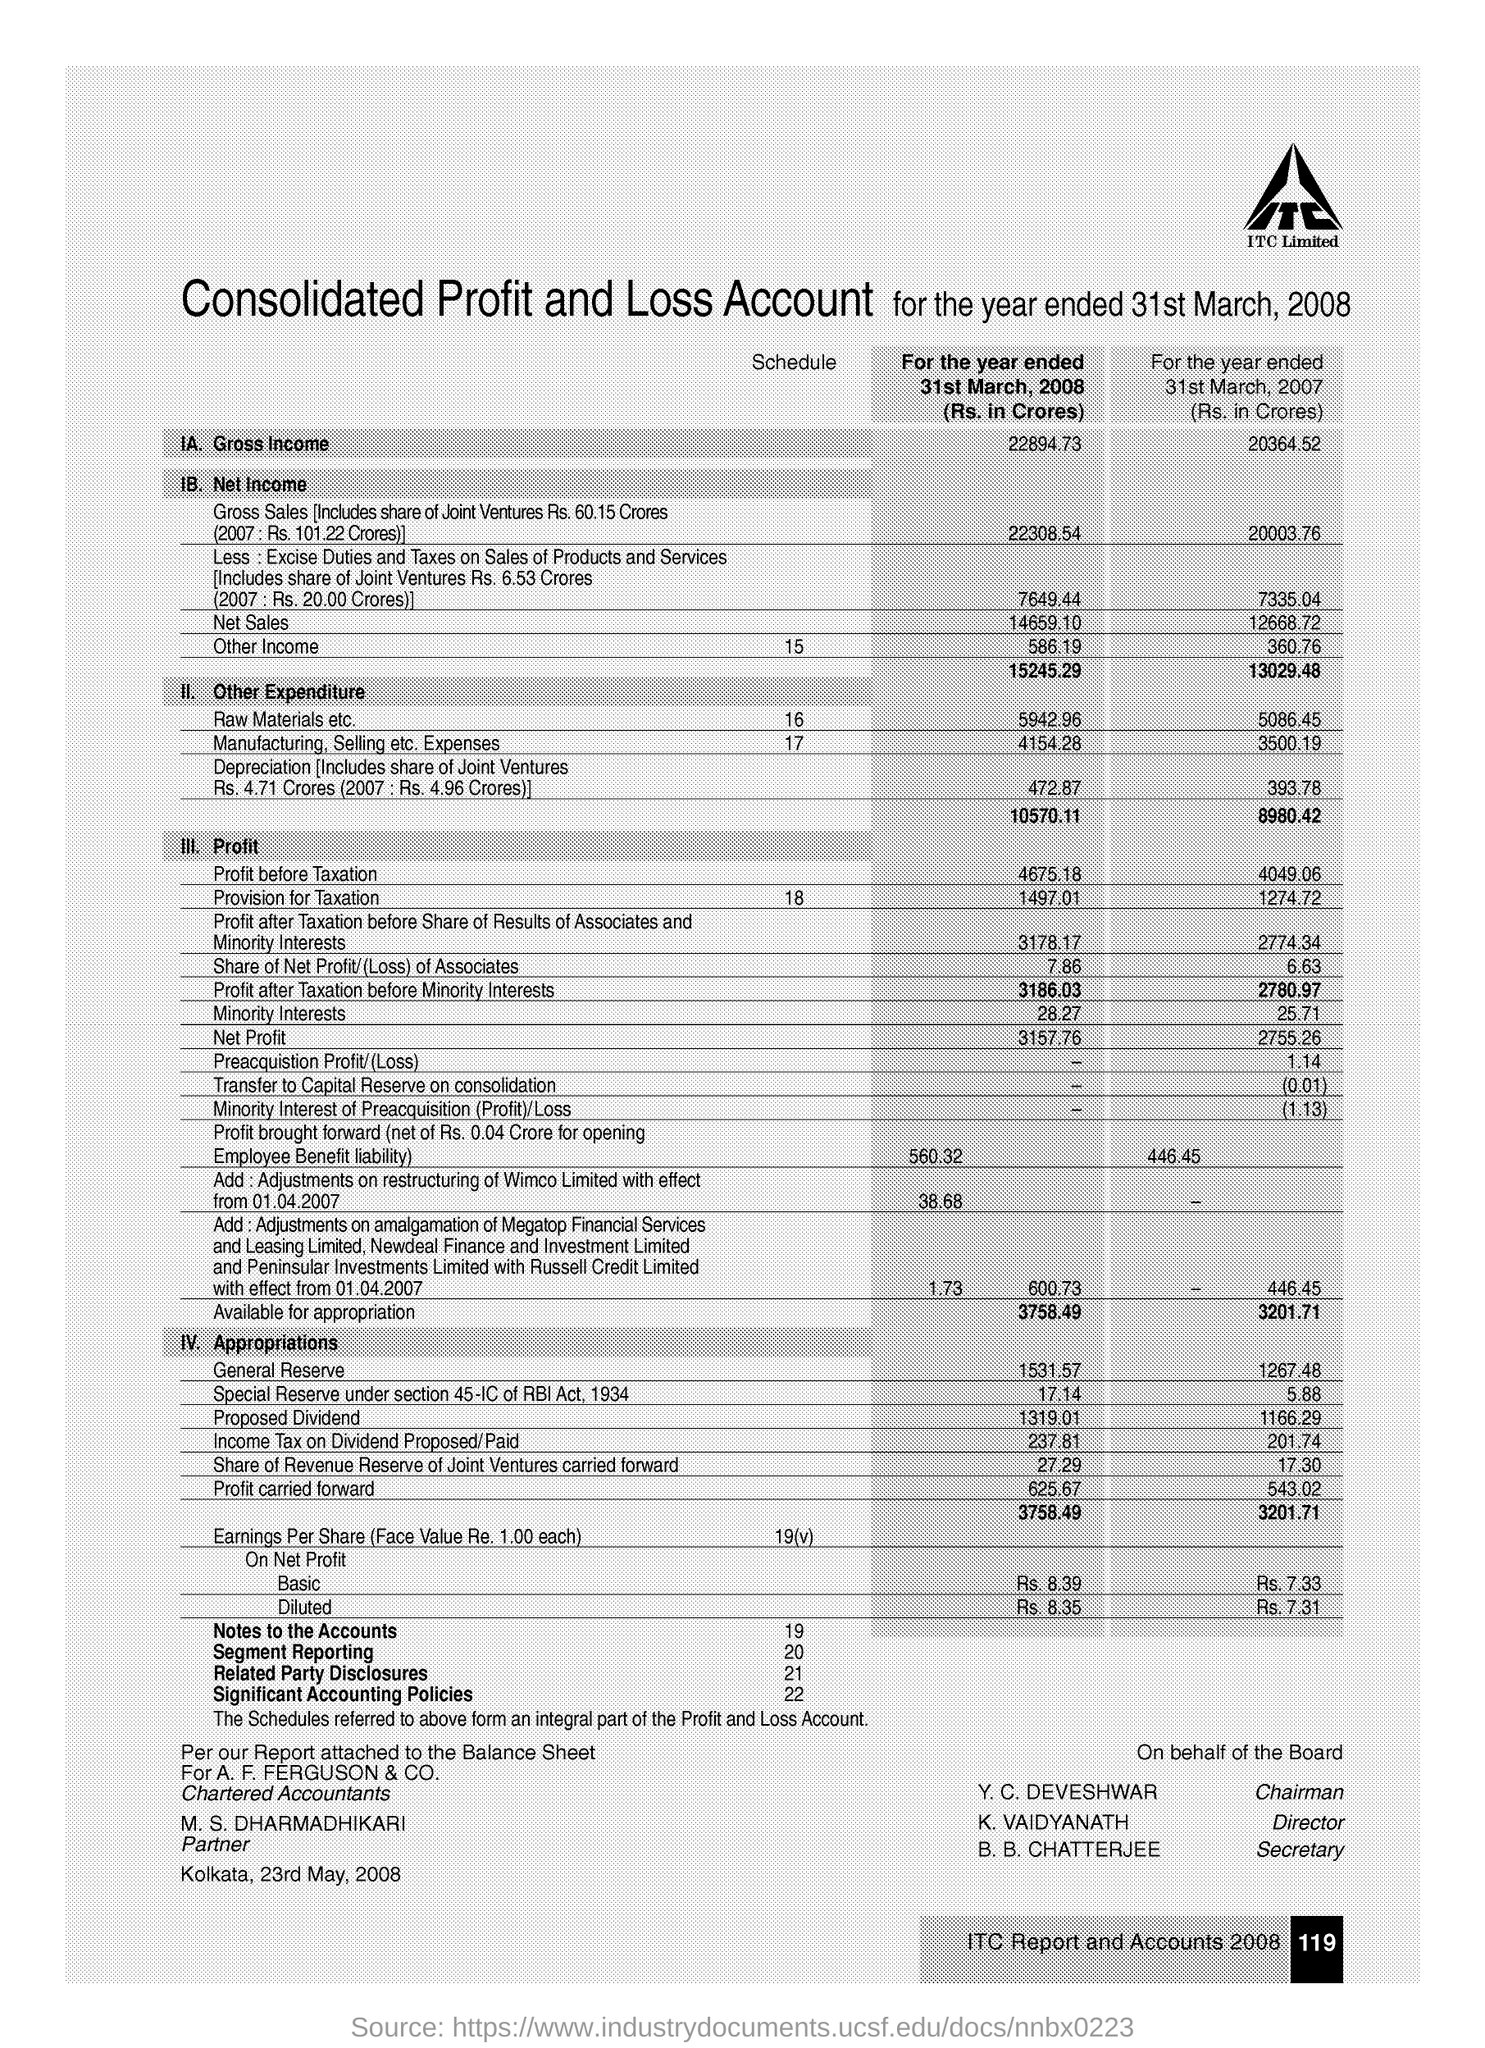What is the 'Gross Income' for the year ended 31st march, 2008?
Make the answer very short. 22894.73. What is the total 'Net Income' for the year ended 31st march, 2007 ?
Your response must be concise. 13029.48. What is the 'profit before taxation' for the year ended 31st march, 2008 ?
Your answer should be compact. 4675.18. Who is the Director ?
Your answer should be compact. K. Vaidyanath. 